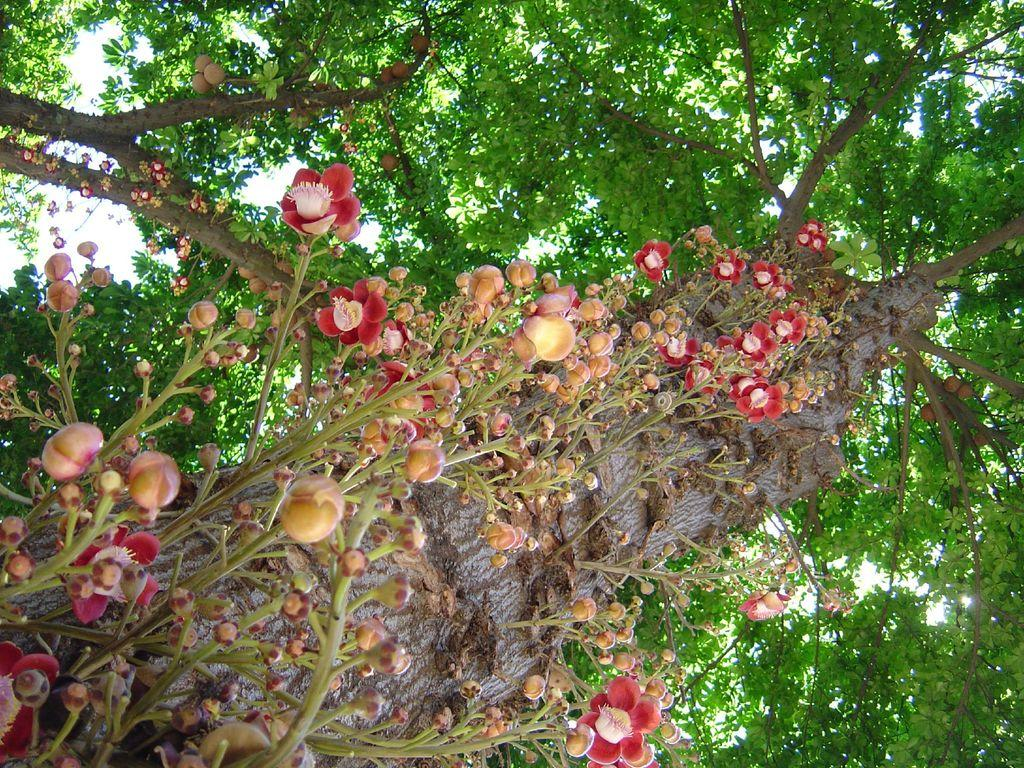What type of vegetation is present in the image? There are flower plants and trees in the image. What can be seen in the background of the image? The sky is visible in the background of the image. What channel is the flower plant watching in the image? There is no television or channel present in the image; it features flower plants and trees. What scent can be detected from the flower plants in the image? The image is visual, and scents cannot be detected from a visual representation. 